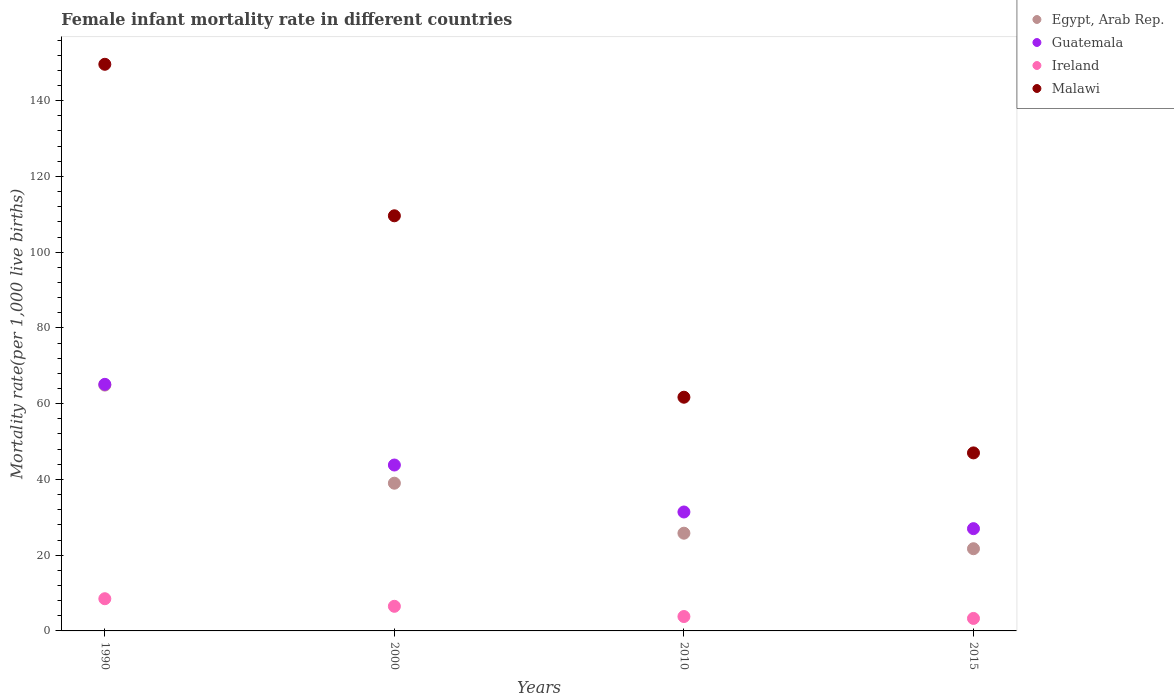Is the number of dotlines equal to the number of legend labels?
Give a very brief answer. Yes. Across all years, what is the minimum female infant mortality rate in Guatemala?
Your response must be concise. 27. In which year was the female infant mortality rate in Malawi minimum?
Provide a succinct answer. 2015. What is the total female infant mortality rate in Malawi in the graph?
Provide a short and direct response. 367.9. What is the difference between the female infant mortality rate in Guatemala in 2000 and that in 2010?
Offer a terse response. 12.4. What is the difference between the female infant mortality rate in Egypt, Arab Rep. in 2000 and the female infant mortality rate in Guatemala in 1990?
Make the answer very short. -26.1. What is the average female infant mortality rate in Malawi per year?
Your answer should be very brief. 91.97. In the year 2000, what is the difference between the female infant mortality rate in Ireland and female infant mortality rate in Egypt, Arab Rep.?
Your answer should be very brief. -32.5. What is the ratio of the female infant mortality rate in Malawi in 1990 to that in 2010?
Your response must be concise. 2.42. Is the female infant mortality rate in Guatemala in 2000 less than that in 2010?
Provide a short and direct response. No. What is the difference between the highest and the second highest female infant mortality rate in Egypt, Arab Rep.?
Your answer should be compact. 25.9. What is the difference between the highest and the lowest female infant mortality rate in Malawi?
Your answer should be very brief. 102.6. Is it the case that in every year, the sum of the female infant mortality rate in Guatemala and female infant mortality rate in Malawi  is greater than the sum of female infant mortality rate in Ireland and female infant mortality rate in Egypt, Arab Rep.?
Keep it short and to the point. Yes. Is it the case that in every year, the sum of the female infant mortality rate in Malawi and female infant mortality rate in Ireland  is greater than the female infant mortality rate in Guatemala?
Your response must be concise. Yes. Does the female infant mortality rate in Malawi monotonically increase over the years?
Your response must be concise. No. How many dotlines are there?
Give a very brief answer. 4. Does the graph contain grids?
Your response must be concise. No. What is the title of the graph?
Give a very brief answer. Female infant mortality rate in different countries. Does "Jamaica" appear as one of the legend labels in the graph?
Your response must be concise. No. What is the label or title of the X-axis?
Offer a terse response. Years. What is the label or title of the Y-axis?
Give a very brief answer. Mortality rate(per 1,0 live births). What is the Mortality rate(per 1,000 live births) of Egypt, Arab Rep. in 1990?
Keep it short and to the point. 64.9. What is the Mortality rate(per 1,000 live births) of Guatemala in 1990?
Your answer should be compact. 65.1. What is the Mortality rate(per 1,000 live births) of Ireland in 1990?
Your response must be concise. 8.5. What is the Mortality rate(per 1,000 live births) of Malawi in 1990?
Give a very brief answer. 149.6. What is the Mortality rate(per 1,000 live births) in Egypt, Arab Rep. in 2000?
Your answer should be compact. 39. What is the Mortality rate(per 1,000 live births) of Guatemala in 2000?
Give a very brief answer. 43.8. What is the Mortality rate(per 1,000 live births) of Ireland in 2000?
Make the answer very short. 6.5. What is the Mortality rate(per 1,000 live births) in Malawi in 2000?
Offer a terse response. 109.6. What is the Mortality rate(per 1,000 live births) in Egypt, Arab Rep. in 2010?
Ensure brevity in your answer.  25.8. What is the Mortality rate(per 1,000 live births) of Guatemala in 2010?
Ensure brevity in your answer.  31.4. What is the Mortality rate(per 1,000 live births) of Malawi in 2010?
Your answer should be compact. 61.7. What is the Mortality rate(per 1,000 live births) in Egypt, Arab Rep. in 2015?
Make the answer very short. 21.7. What is the Mortality rate(per 1,000 live births) of Ireland in 2015?
Your answer should be very brief. 3.3. What is the Mortality rate(per 1,000 live births) in Malawi in 2015?
Provide a short and direct response. 47. Across all years, what is the maximum Mortality rate(per 1,000 live births) in Egypt, Arab Rep.?
Your answer should be compact. 64.9. Across all years, what is the maximum Mortality rate(per 1,000 live births) of Guatemala?
Provide a short and direct response. 65.1. Across all years, what is the maximum Mortality rate(per 1,000 live births) of Ireland?
Provide a short and direct response. 8.5. Across all years, what is the maximum Mortality rate(per 1,000 live births) in Malawi?
Provide a succinct answer. 149.6. Across all years, what is the minimum Mortality rate(per 1,000 live births) of Egypt, Arab Rep.?
Your answer should be compact. 21.7. Across all years, what is the minimum Mortality rate(per 1,000 live births) of Malawi?
Give a very brief answer. 47. What is the total Mortality rate(per 1,000 live births) in Egypt, Arab Rep. in the graph?
Provide a succinct answer. 151.4. What is the total Mortality rate(per 1,000 live births) in Guatemala in the graph?
Provide a short and direct response. 167.3. What is the total Mortality rate(per 1,000 live births) in Ireland in the graph?
Provide a short and direct response. 22.1. What is the total Mortality rate(per 1,000 live births) of Malawi in the graph?
Your answer should be very brief. 367.9. What is the difference between the Mortality rate(per 1,000 live births) of Egypt, Arab Rep. in 1990 and that in 2000?
Give a very brief answer. 25.9. What is the difference between the Mortality rate(per 1,000 live births) in Guatemala in 1990 and that in 2000?
Your answer should be very brief. 21.3. What is the difference between the Mortality rate(per 1,000 live births) of Malawi in 1990 and that in 2000?
Your answer should be very brief. 40. What is the difference between the Mortality rate(per 1,000 live births) in Egypt, Arab Rep. in 1990 and that in 2010?
Make the answer very short. 39.1. What is the difference between the Mortality rate(per 1,000 live births) of Guatemala in 1990 and that in 2010?
Your answer should be compact. 33.7. What is the difference between the Mortality rate(per 1,000 live births) in Malawi in 1990 and that in 2010?
Make the answer very short. 87.9. What is the difference between the Mortality rate(per 1,000 live births) in Egypt, Arab Rep. in 1990 and that in 2015?
Your answer should be compact. 43.2. What is the difference between the Mortality rate(per 1,000 live births) in Guatemala in 1990 and that in 2015?
Provide a short and direct response. 38.1. What is the difference between the Mortality rate(per 1,000 live births) of Malawi in 1990 and that in 2015?
Your answer should be compact. 102.6. What is the difference between the Mortality rate(per 1,000 live births) of Egypt, Arab Rep. in 2000 and that in 2010?
Your answer should be very brief. 13.2. What is the difference between the Mortality rate(per 1,000 live births) of Malawi in 2000 and that in 2010?
Ensure brevity in your answer.  47.9. What is the difference between the Mortality rate(per 1,000 live births) in Egypt, Arab Rep. in 2000 and that in 2015?
Provide a short and direct response. 17.3. What is the difference between the Mortality rate(per 1,000 live births) in Ireland in 2000 and that in 2015?
Your answer should be very brief. 3.2. What is the difference between the Mortality rate(per 1,000 live births) of Malawi in 2000 and that in 2015?
Offer a terse response. 62.6. What is the difference between the Mortality rate(per 1,000 live births) in Egypt, Arab Rep. in 2010 and that in 2015?
Your response must be concise. 4.1. What is the difference between the Mortality rate(per 1,000 live births) in Guatemala in 2010 and that in 2015?
Provide a succinct answer. 4.4. What is the difference between the Mortality rate(per 1,000 live births) in Ireland in 2010 and that in 2015?
Give a very brief answer. 0.5. What is the difference between the Mortality rate(per 1,000 live births) of Malawi in 2010 and that in 2015?
Your answer should be compact. 14.7. What is the difference between the Mortality rate(per 1,000 live births) in Egypt, Arab Rep. in 1990 and the Mortality rate(per 1,000 live births) in Guatemala in 2000?
Offer a terse response. 21.1. What is the difference between the Mortality rate(per 1,000 live births) in Egypt, Arab Rep. in 1990 and the Mortality rate(per 1,000 live births) in Ireland in 2000?
Your answer should be very brief. 58.4. What is the difference between the Mortality rate(per 1,000 live births) of Egypt, Arab Rep. in 1990 and the Mortality rate(per 1,000 live births) of Malawi in 2000?
Offer a terse response. -44.7. What is the difference between the Mortality rate(per 1,000 live births) of Guatemala in 1990 and the Mortality rate(per 1,000 live births) of Ireland in 2000?
Keep it short and to the point. 58.6. What is the difference between the Mortality rate(per 1,000 live births) in Guatemala in 1990 and the Mortality rate(per 1,000 live births) in Malawi in 2000?
Provide a short and direct response. -44.5. What is the difference between the Mortality rate(per 1,000 live births) of Ireland in 1990 and the Mortality rate(per 1,000 live births) of Malawi in 2000?
Offer a terse response. -101.1. What is the difference between the Mortality rate(per 1,000 live births) of Egypt, Arab Rep. in 1990 and the Mortality rate(per 1,000 live births) of Guatemala in 2010?
Your response must be concise. 33.5. What is the difference between the Mortality rate(per 1,000 live births) in Egypt, Arab Rep. in 1990 and the Mortality rate(per 1,000 live births) in Ireland in 2010?
Offer a terse response. 61.1. What is the difference between the Mortality rate(per 1,000 live births) in Guatemala in 1990 and the Mortality rate(per 1,000 live births) in Ireland in 2010?
Keep it short and to the point. 61.3. What is the difference between the Mortality rate(per 1,000 live births) of Guatemala in 1990 and the Mortality rate(per 1,000 live births) of Malawi in 2010?
Offer a very short reply. 3.4. What is the difference between the Mortality rate(per 1,000 live births) of Ireland in 1990 and the Mortality rate(per 1,000 live births) of Malawi in 2010?
Offer a terse response. -53.2. What is the difference between the Mortality rate(per 1,000 live births) in Egypt, Arab Rep. in 1990 and the Mortality rate(per 1,000 live births) in Guatemala in 2015?
Give a very brief answer. 37.9. What is the difference between the Mortality rate(per 1,000 live births) of Egypt, Arab Rep. in 1990 and the Mortality rate(per 1,000 live births) of Ireland in 2015?
Your response must be concise. 61.6. What is the difference between the Mortality rate(per 1,000 live births) in Guatemala in 1990 and the Mortality rate(per 1,000 live births) in Ireland in 2015?
Keep it short and to the point. 61.8. What is the difference between the Mortality rate(per 1,000 live births) of Guatemala in 1990 and the Mortality rate(per 1,000 live births) of Malawi in 2015?
Make the answer very short. 18.1. What is the difference between the Mortality rate(per 1,000 live births) of Ireland in 1990 and the Mortality rate(per 1,000 live births) of Malawi in 2015?
Your answer should be compact. -38.5. What is the difference between the Mortality rate(per 1,000 live births) in Egypt, Arab Rep. in 2000 and the Mortality rate(per 1,000 live births) in Ireland in 2010?
Make the answer very short. 35.2. What is the difference between the Mortality rate(per 1,000 live births) in Egypt, Arab Rep. in 2000 and the Mortality rate(per 1,000 live births) in Malawi in 2010?
Your answer should be compact. -22.7. What is the difference between the Mortality rate(per 1,000 live births) of Guatemala in 2000 and the Mortality rate(per 1,000 live births) of Malawi in 2010?
Keep it short and to the point. -17.9. What is the difference between the Mortality rate(per 1,000 live births) in Ireland in 2000 and the Mortality rate(per 1,000 live births) in Malawi in 2010?
Offer a terse response. -55.2. What is the difference between the Mortality rate(per 1,000 live births) in Egypt, Arab Rep. in 2000 and the Mortality rate(per 1,000 live births) in Guatemala in 2015?
Your answer should be compact. 12. What is the difference between the Mortality rate(per 1,000 live births) of Egypt, Arab Rep. in 2000 and the Mortality rate(per 1,000 live births) of Ireland in 2015?
Your answer should be very brief. 35.7. What is the difference between the Mortality rate(per 1,000 live births) of Egypt, Arab Rep. in 2000 and the Mortality rate(per 1,000 live births) of Malawi in 2015?
Make the answer very short. -8. What is the difference between the Mortality rate(per 1,000 live births) in Guatemala in 2000 and the Mortality rate(per 1,000 live births) in Ireland in 2015?
Your answer should be compact. 40.5. What is the difference between the Mortality rate(per 1,000 live births) of Ireland in 2000 and the Mortality rate(per 1,000 live births) of Malawi in 2015?
Your answer should be very brief. -40.5. What is the difference between the Mortality rate(per 1,000 live births) of Egypt, Arab Rep. in 2010 and the Mortality rate(per 1,000 live births) of Ireland in 2015?
Your answer should be compact. 22.5. What is the difference between the Mortality rate(per 1,000 live births) of Egypt, Arab Rep. in 2010 and the Mortality rate(per 1,000 live births) of Malawi in 2015?
Your response must be concise. -21.2. What is the difference between the Mortality rate(per 1,000 live births) of Guatemala in 2010 and the Mortality rate(per 1,000 live births) of Ireland in 2015?
Offer a terse response. 28.1. What is the difference between the Mortality rate(per 1,000 live births) of Guatemala in 2010 and the Mortality rate(per 1,000 live births) of Malawi in 2015?
Provide a short and direct response. -15.6. What is the difference between the Mortality rate(per 1,000 live births) of Ireland in 2010 and the Mortality rate(per 1,000 live births) of Malawi in 2015?
Your answer should be very brief. -43.2. What is the average Mortality rate(per 1,000 live births) of Egypt, Arab Rep. per year?
Offer a very short reply. 37.85. What is the average Mortality rate(per 1,000 live births) of Guatemala per year?
Ensure brevity in your answer.  41.83. What is the average Mortality rate(per 1,000 live births) in Ireland per year?
Offer a terse response. 5.53. What is the average Mortality rate(per 1,000 live births) in Malawi per year?
Make the answer very short. 91.97. In the year 1990, what is the difference between the Mortality rate(per 1,000 live births) of Egypt, Arab Rep. and Mortality rate(per 1,000 live births) of Guatemala?
Your answer should be compact. -0.2. In the year 1990, what is the difference between the Mortality rate(per 1,000 live births) in Egypt, Arab Rep. and Mortality rate(per 1,000 live births) in Ireland?
Make the answer very short. 56.4. In the year 1990, what is the difference between the Mortality rate(per 1,000 live births) of Egypt, Arab Rep. and Mortality rate(per 1,000 live births) of Malawi?
Keep it short and to the point. -84.7. In the year 1990, what is the difference between the Mortality rate(per 1,000 live births) of Guatemala and Mortality rate(per 1,000 live births) of Ireland?
Offer a very short reply. 56.6. In the year 1990, what is the difference between the Mortality rate(per 1,000 live births) in Guatemala and Mortality rate(per 1,000 live births) in Malawi?
Provide a short and direct response. -84.5. In the year 1990, what is the difference between the Mortality rate(per 1,000 live births) in Ireland and Mortality rate(per 1,000 live births) in Malawi?
Offer a very short reply. -141.1. In the year 2000, what is the difference between the Mortality rate(per 1,000 live births) in Egypt, Arab Rep. and Mortality rate(per 1,000 live births) in Guatemala?
Ensure brevity in your answer.  -4.8. In the year 2000, what is the difference between the Mortality rate(per 1,000 live births) in Egypt, Arab Rep. and Mortality rate(per 1,000 live births) in Ireland?
Offer a very short reply. 32.5. In the year 2000, what is the difference between the Mortality rate(per 1,000 live births) in Egypt, Arab Rep. and Mortality rate(per 1,000 live births) in Malawi?
Give a very brief answer. -70.6. In the year 2000, what is the difference between the Mortality rate(per 1,000 live births) in Guatemala and Mortality rate(per 1,000 live births) in Ireland?
Provide a succinct answer. 37.3. In the year 2000, what is the difference between the Mortality rate(per 1,000 live births) in Guatemala and Mortality rate(per 1,000 live births) in Malawi?
Your answer should be compact. -65.8. In the year 2000, what is the difference between the Mortality rate(per 1,000 live births) in Ireland and Mortality rate(per 1,000 live births) in Malawi?
Keep it short and to the point. -103.1. In the year 2010, what is the difference between the Mortality rate(per 1,000 live births) in Egypt, Arab Rep. and Mortality rate(per 1,000 live births) in Guatemala?
Keep it short and to the point. -5.6. In the year 2010, what is the difference between the Mortality rate(per 1,000 live births) of Egypt, Arab Rep. and Mortality rate(per 1,000 live births) of Malawi?
Provide a short and direct response. -35.9. In the year 2010, what is the difference between the Mortality rate(per 1,000 live births) of Guatemala and Mortality rate(per 1,000 live births) of Ireland?
Provide a succinct answer. 27.6. In the year 2010, what is the difference between the Mortality rate(per 1,000 live births) in Guatemala and Mortality rate(per 1,000 live births) in Malawi?
Your answer should be compact. -30.3. In the year 2010, what is the difference between the Mortality rate(per 1,000 live births) of Ireland and Mortality rate(per 1,000 live births) of Malawi?
Offer a terse response. -57.9. In the year 2015, what is the difference between the Mortality rate(per 1,000 live births) of Egypt, Arab Rep. and Mortality rate(per 1,000 live births) of Guatemala?
Make the answer very short. -5.3. In the year 2015, what is the difference between the Mortality rate(per 1,000 live births) in Egypt, Arab Rep. and Mortality rate(per 1,000 live births) in Malawi?
Ensure brevity in your answer.  -25.3. In the year 2015, what is the difference between the Mortality rate(per 1,000 live births) of Guatemala and Mortality rate(per 1,000 live births) of Ireland?
Your response must be concise. 23.7. In the year 2015, what is the difference between the Mortality rate(per 1,000 live births) in Ireland and Mortality rate(per 1,000 live births) in Malawi?
Your answer should be compact. -43.7. What is the ratio of the Mortality rate(per 1,000 live births) of Egypt, Arab Rep. in 1990 to that in 2000?
Ensure brevity in your answer.  1.66. What is the ratio of the Mortality rate(per 1,000 live births) of Guatemala in 1990 to that in 2000?
Make the answer very short. 1.49. What is the ratio of the Mortality rate(per 1,000 live births) of Ireland in 1990 to that in 2000?
Give a very brief answer. 1.31. What is the ratio of the Mortality rate(per 1,000 live births) of Malawi in 1990 to that in 2000?
Provide a succinct answer. 1.36. What is the ratio of the Mortality rate(per 1,000 live births) of Egypt, Arab Rep. in 1990 to that in 2010?
Provide a short and direct response. 2.52. What is the ratio of the Mortality rate(per 1,000 live births) in Guatemala in 1990 to that in 2010?
Your response must be concise. 2.07. What is the ratio of the Mortality rate(per 1,000 live births) of Ireland in 1990 to that in 2010?
Keep it short and to the point. 2.24. What is the ratio of the Mortality rate(per 1,000 live births) in Malawi in 1990 to that in 2010?
Your answer should be very brief. 2.42. What is the ratio of the Mortality rate(per 1,000 live births) of Egypt, Arab Rep. in 1990 to that in 2015?
Make the answer very short. 2.99. What is the ratio of the Mortality rate(per 1,000 live births) in Guatemala in 1990 to that in 2015?
Give a very brief answer. 2.41. What is the ratio of the Mortality rate(per 1,000 live births) in Ireland in 1990 to that in 2015?
Your answer should be compact. 2.58. What is the ratio of the Mortality rate(per 1,000 live births) in Malawi in 1990 to that in 2015?
Offer a very short reply. 3.18. What is the ratio of the Mortality rate(per 1,000 live births) in Egypt, Arab Rep. in 2000 to that in 2010?
Offer a terse response. 1.51. What is the ratio of the Mortality rate(per 1,000 live births) of Guatemala in 2000 to that in 2010?
Provide a succinct answer. 1.39. What is the ratio of the Mortality rate(per 1,000 live births) in Ireland in 2000 to that in 2010?
Ensure brevity in your answer.  1.71. What is the ratio of the Mortality rate(per 1,000 live births) in Malawi in 2000 to that in 2010?
Offer a terse response. 1.78. What is the ratio of the Mortality rate(per 1,000 live births) of Egypt, Arab Rep. in 2000 to that in 2015?
Provide a short and direct response. 1.8. What is the ratio of the Mortality rate(per 1,000 live births) in Guatemala in 2000 to that in 2015?
Provide a short and direct response. 1.62. What is the ratio of the Mortality rate(per 1,000 live births) in Ireland in 2000 to that in 2015?
Provide a short and direct response. 1.97. What is the ratio of the Mortality rate(per 1,000 live births) of Malawi in 2000 to that in 2015?
Your response must be concise. 2.33. What is the ratio of the Mortality rate(per 1,000 live births) of Egypt, Arab Rep. in 2010 to that in 2015?
Offer a terse response. 1.19. What is the ratio of the Mortality rate(per 1,000 live births) in Guatemala in 2010 to that in 2015?
Ensure brevity in your answer.  1.16. What is the ratio of the Mortality rate(per 1,000 live births) of Ireland in 2010 to that in 2015?
Give a very brief answer. 1.15. What is the ratio of the Mortality rate(per 1,000 live births) of Malawi in 2010 to that in 2015?
Offer a very short reply. 1.31. What is the difference between the highest and the second highest Mortality rate(per 1,000 live births) of Egypt, Arab Rep.?
Make the answer very short. 25.9. What is the difference between the highest and the second highest Mortality rate(per 1,000 live births) in Guatemala?
Provide a succinct answer. 21.3. What is the difference between the highest and the lowest Mortality rate(per 1,000 live births) in Egypt, Arab Rep.?
Make the answer very short. 43.2. What is the difference between the highest and the lowest Mortality rate(per 1,000 live births) of Guatemala?
Provide a short and direct response. 38.1. What is the difference between the highest and the lowest Mortality rate(per 1,000 live births) of Ireland?
Provide a succinct answer. 5.2. What is the difference between the highest and the lowest Mortality rate(per 1,000 live births) of Malawi?
Make the answer very short. 102.6. 